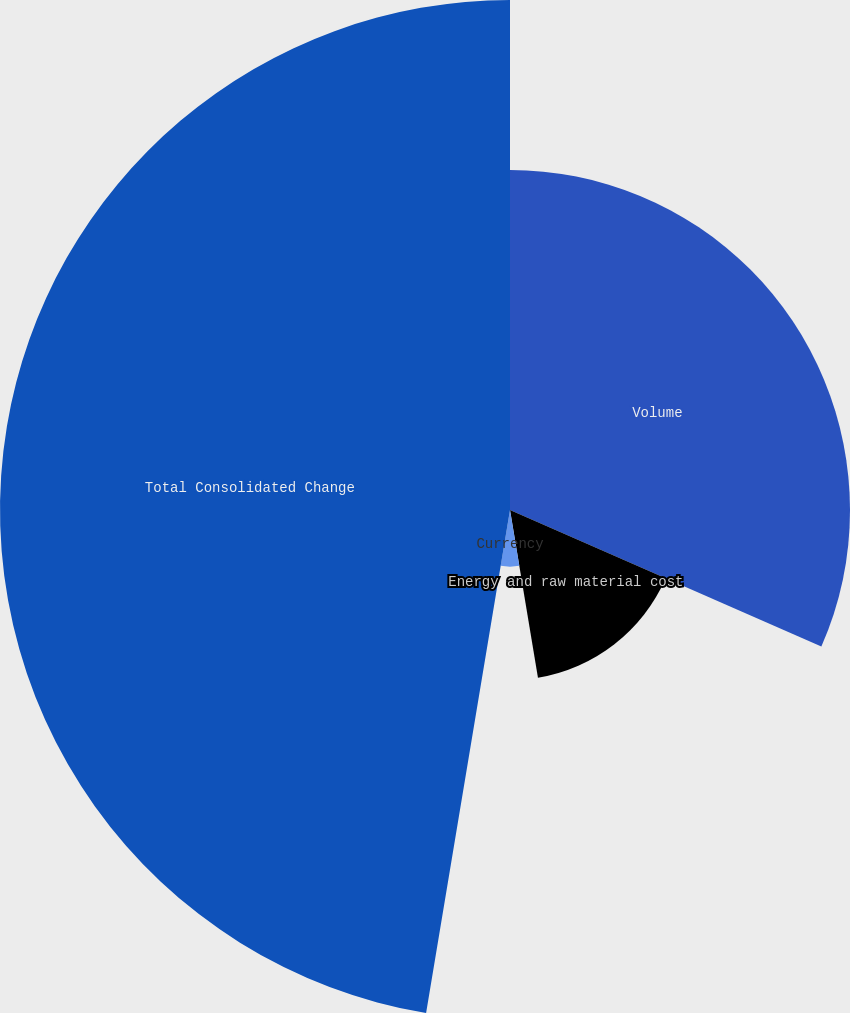Convert chart. <chart><loc_0><loc_0><loc_500><loc_500><pie_chart><fcel>Volume<fcel>Energy and raw material cost<fcel>Currency<fcel>Total Consolidated Change<nl><fcel>31.58%<fcel>15.79%<fcel>5.26%<fcel>47.37%<nl></chart> 